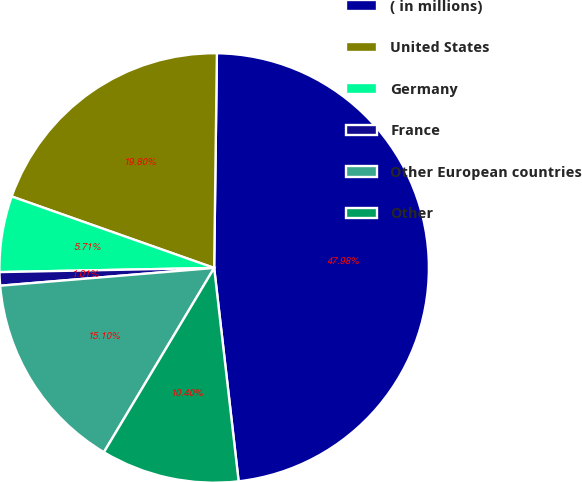Convert chart to OTSL. <chart><loc_0><loc_0><loc_500><loc_500><pie_chart><fcel>( in millions)<fcel>United States<fcel>Germany<fcel>France<fcel>Other European countries<fcel>Other<nl><fcel>47.98%<fcel>19.8%<fcel>5.71%<fcel>1.01%<fcel>15.1%<fcel>10.4%<nl></chart> 